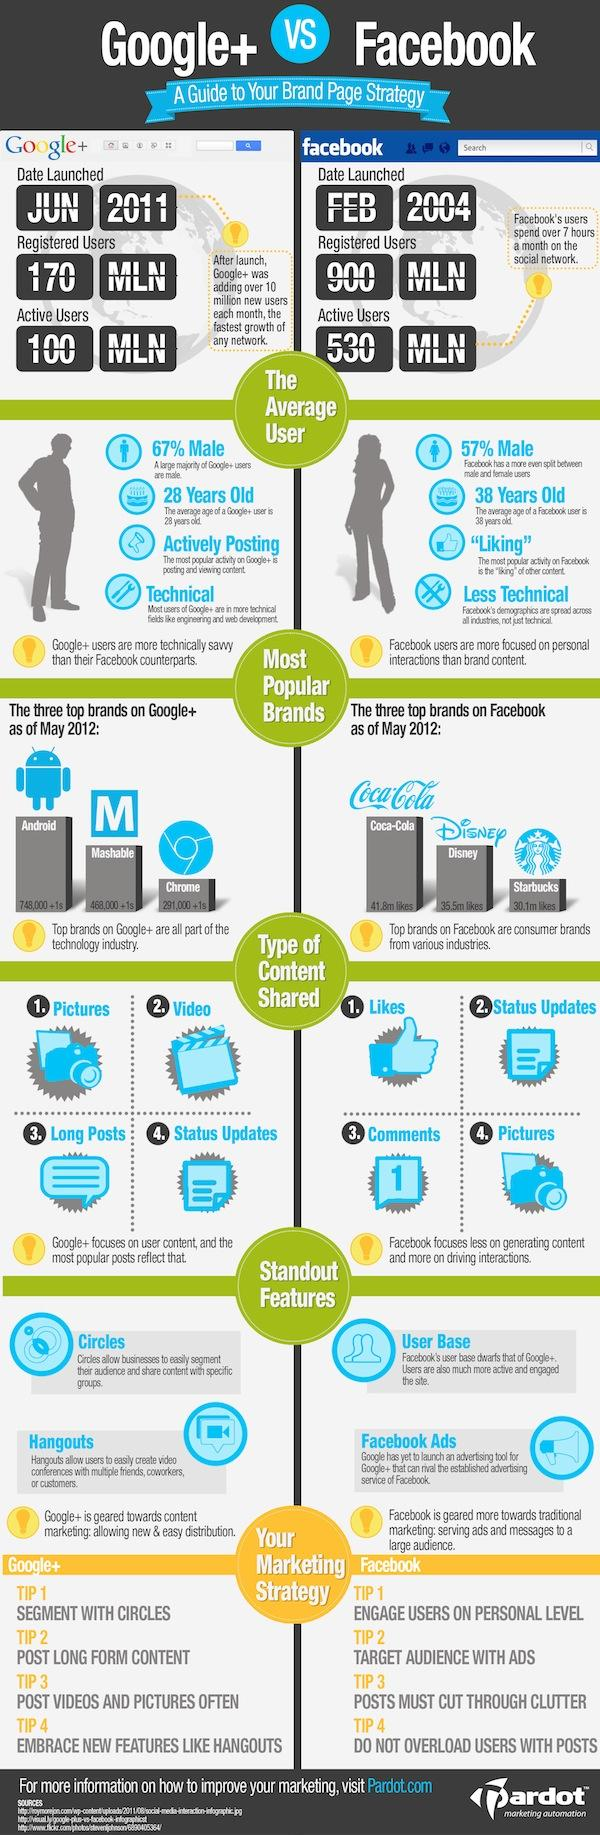List a handful of essential elements in this visual. Facebook has approximately 730 million more users than Google+. Coca-Cola is the most popular brand on Facebook, Starbucks, Disney, and other social media platforms. Facebook is a social media platform that is widely known for its user base and the ability to utilize Facebook ads for promoting businesses and brands. Mashable is the second most popular brand in Google +, Chrome, and Android. Facebook was launched in the month of February. 